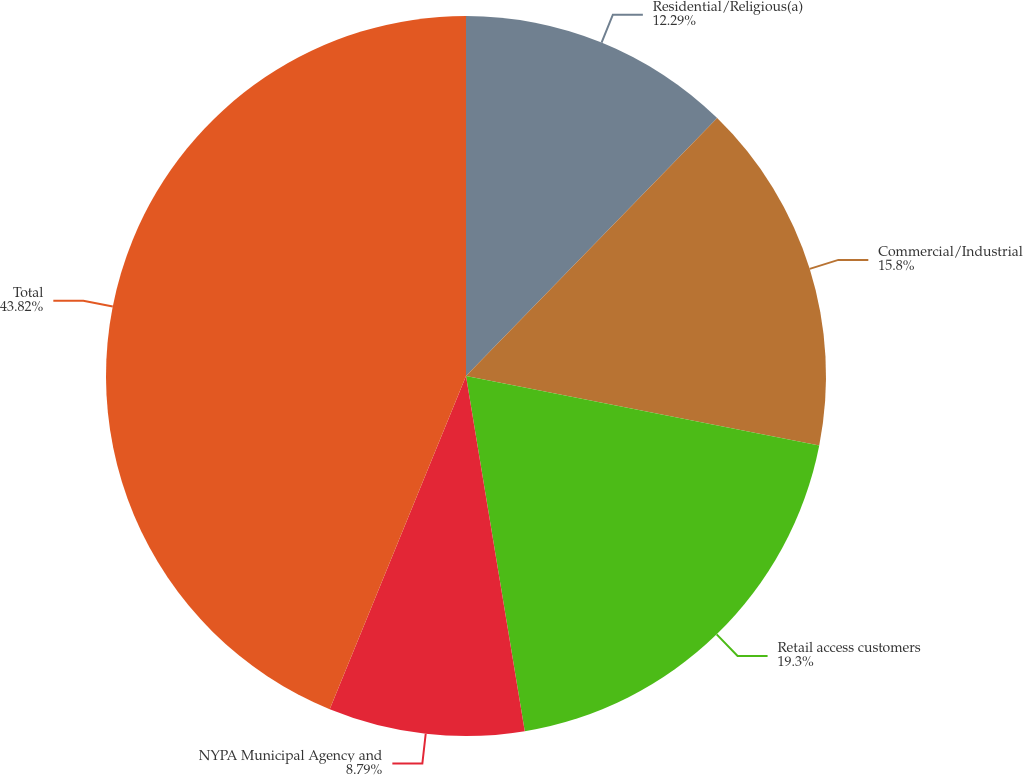Convert chart to OTSL. <chart><loc_0><loc_0><loc_500><loc_500><pie_chart><fcel>Residential/Religious(a)<fcel>Commercial/Industrial<fcel>Retail access customers<fcel>NYPA Municipal Agency and<fcel>Total<nl><fcel>12.29%<fcel>15.8%<fcel>19.3%<fcel>8.79%<fcel>43.82%<nl></chart> 